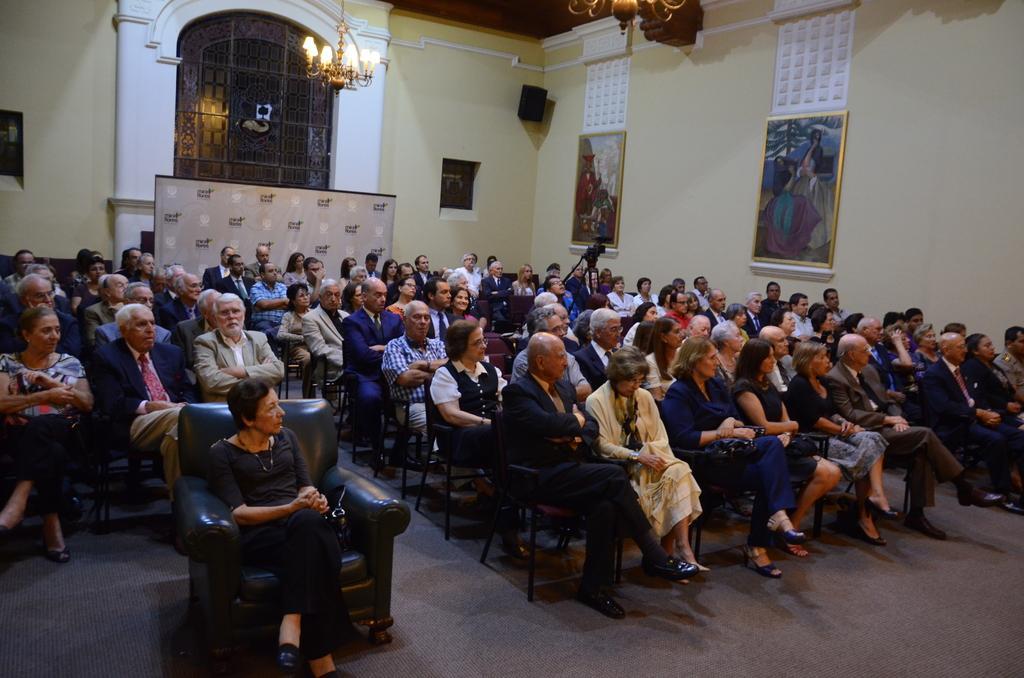Can you describe this image briefly? This picture is clicked inside. In the foreground we can see the group of people sitting on the chairs. In the background we can see a window, picture frames hanging on the wall and a speaker which is wall mounted. At the top there is a roof and the chandeliers. 